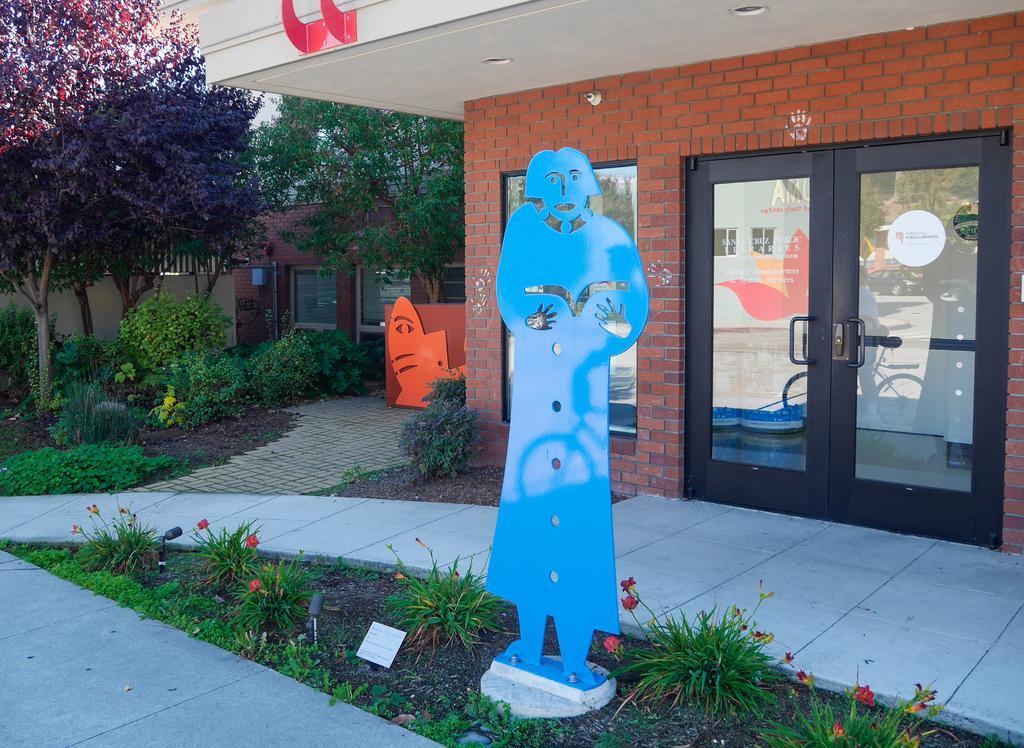Please provide a concise description of this image. In this picture we can see houses, glass door, objects, plants, board, flowers and trees. 